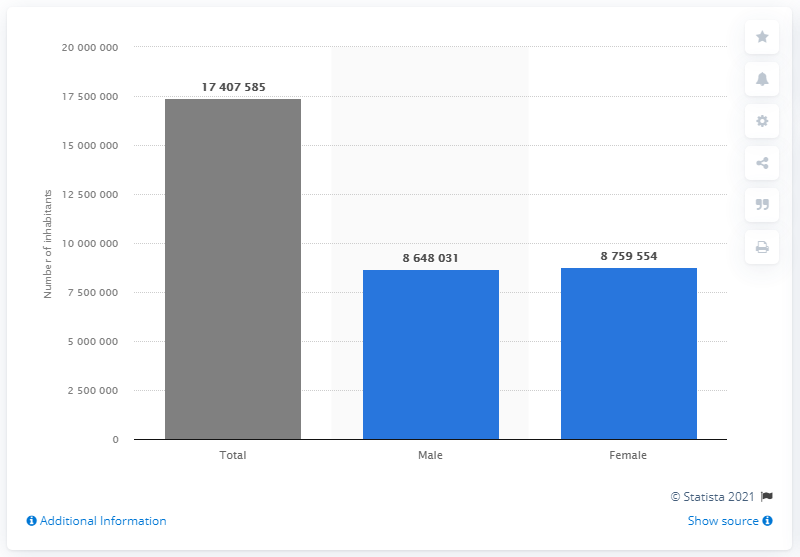Indicate a few pertinent items in this graphic. On January 1, 2020, it is estimated that approximately 875,954 women lived in the Netherlands. 